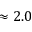<formula> <loc_0><loc_0><loc_500><loc_500>\approx 2 . 0</formula> 